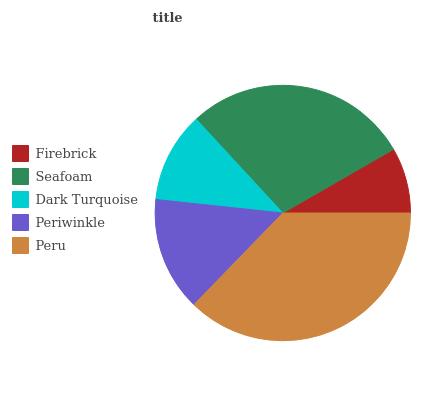Is Firebrick the minimum?
Answer yes or no. Yes. Is Peru the maximum?
Answer yes or no. Yes. Is Seafoam the minimum?
Answer yes or no. No. Is Seafoam the maximum?
Answer yes or no. No. Is Seafoam greater than Firebrick?
Answer yes or no. Yes. Is Firebrick less than Seafoam?
Answer yes or no. Yes. Is Firebrick greater than Seafoam?
Answer yes or no. No. Is Seafoam less than Firebrick?
Answer yes or no. No. Is Periwinkle the high median?
Answer yes or no. Yes. Is Periwinkle the low median?
Answer yes or no. Yes. Is Peru the high median?
Answer yes or no. No. Is Firebrick the low median?
Answer yes or no. No. 